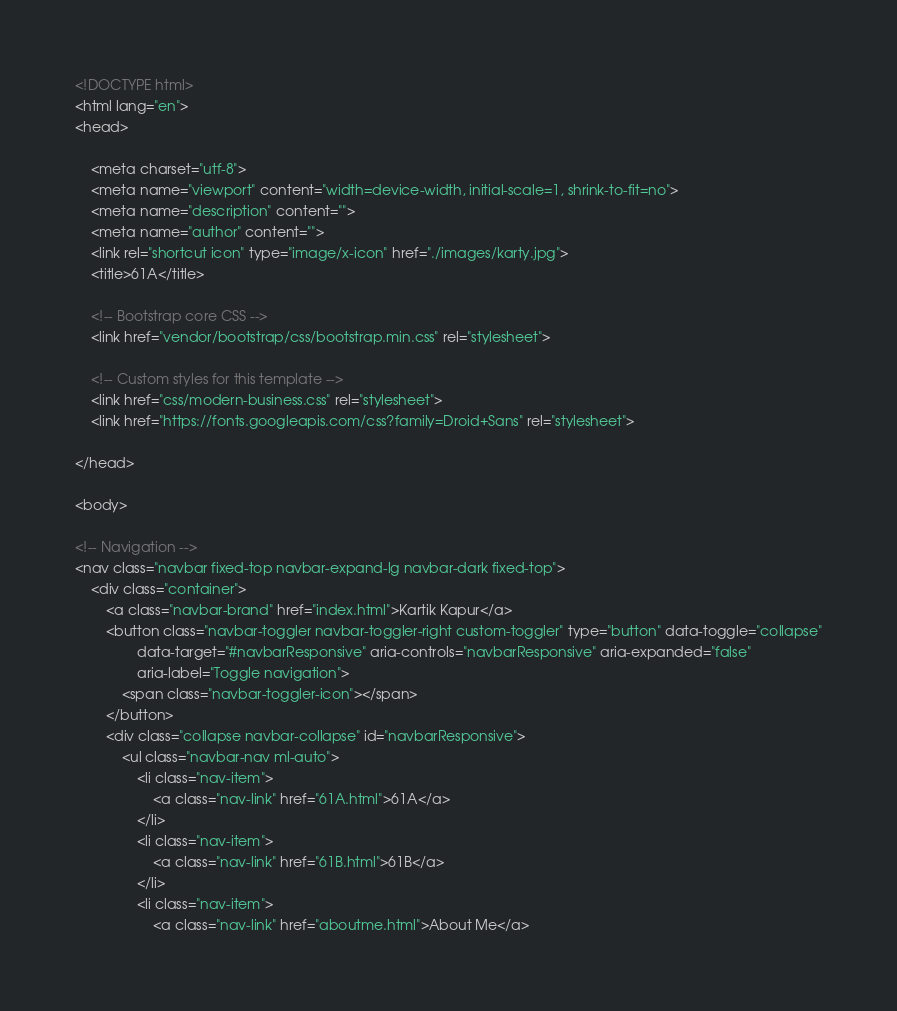Convert code to text. <code><loc_0><loc_0><loc_500><loc_500><_HTML_><!DOCTYPE html>
<html lang="en">
<head>

    <meta charset="utf-8">
    <meta name="viewport" content="width=device-width, initial-scale=1, shrink-to-fit=no">
    <meta name="description" content="">
    <meta name="author" content="">
    <link rel="shortcut icon" type="image/x-icon" href="./images/karty.jpg">
    <title>61A</title>

    <!-- Bootstrap core CSS -->
    <link href="vendor/bootstrap/css/bootstrap.min.css" rel="stylesheet">

    <!-- Custom styles for this template -->
    <link href="css/modern-business.css" rel="stylesheet">
    <link href="https://fonts.googleapis.com/css?family=Droid+Sans" rel="stylesheet">

</head>

<body>

<!-- Navigation -->
<nav class="navbar fixed-top navbar-expand-lg navbar-dark fixed-top">
    <div class="container">
        <a class="navbar-brand" href="index.html">Kartik Kapur</a>
        <button class="navbar-toggler navbar-toggler-right custom-toggler" type="button" data-toggle="collapse"
                data-target="#navbarResponsive" aria-controls="navbarResponsive" aria-expanded="false"
                aria-label="Toggle navigation">
            <span class="navbar-toggler-icon"></span>
        </button>
        <div class="collapse navbar-collapse" id="navbarResponsive">
            <ul class="navbar-nav ml-auto">
                <li class="nav-item">
                    <a class="nav-link" href="61A.html">61A</a>
                </li>
                <li class="nav-item">
                    <a class="nav-link" href="61B.html">61B</a>
                </li>
                <li class="nav-item">
                    <a class="nav-link" href="aboutme.html">About Me</a></code> 